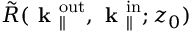Convert formula to latex. <formula><loc_0><loc_0><loc_500><loc_500>\tilde { R } ( k _ { \| } ^ { o u t } , k _ { \| } ^ { i n } ; z _ { 0 } )</formula> 